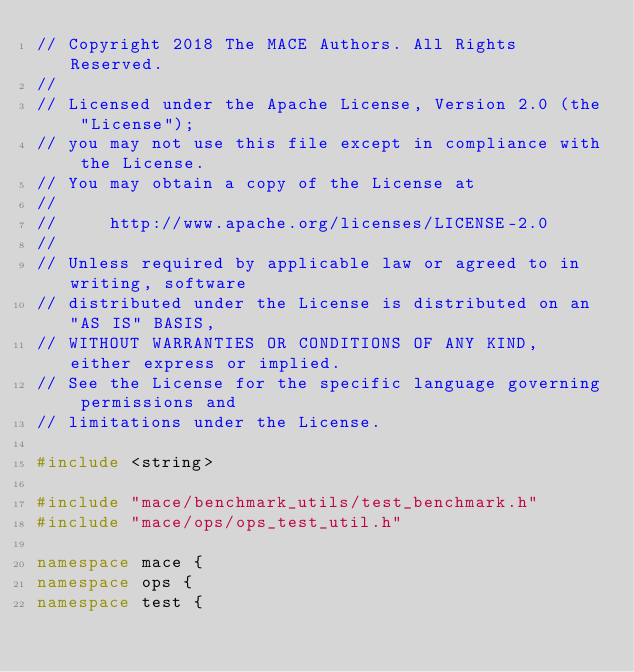Convert code to text. <code><loc_0><loc_0><loc_500><loc_500><_C++_>// Copyright 2018 The MACE Authors. All Rights Reserved.
//
// Licensed under the Apache License, Version 2.0 (the "License");
// you may not use this file except in compliance with the License.
// You may obtain a copy of the License at
//
//     http://www.apache.org/licenses/LICENSE-2.0
//
// Unless required by applicable law or agreed to in writing, software
// distributed under the License is distributed on an "AS IS" BASIS,
// WITHOUT WARRANTIES OR CONDITIONS OF ANY KIND, either express or implied.
// See the License for the specific language governing permissions and
// limitations under the License.

#include <string>

#include "mace/benchmark_utils/test_benchmark.h"
#include "mace/ops/ops_test_util.h"

namespace mace {
namespace ops {
namespace test {
</code> 